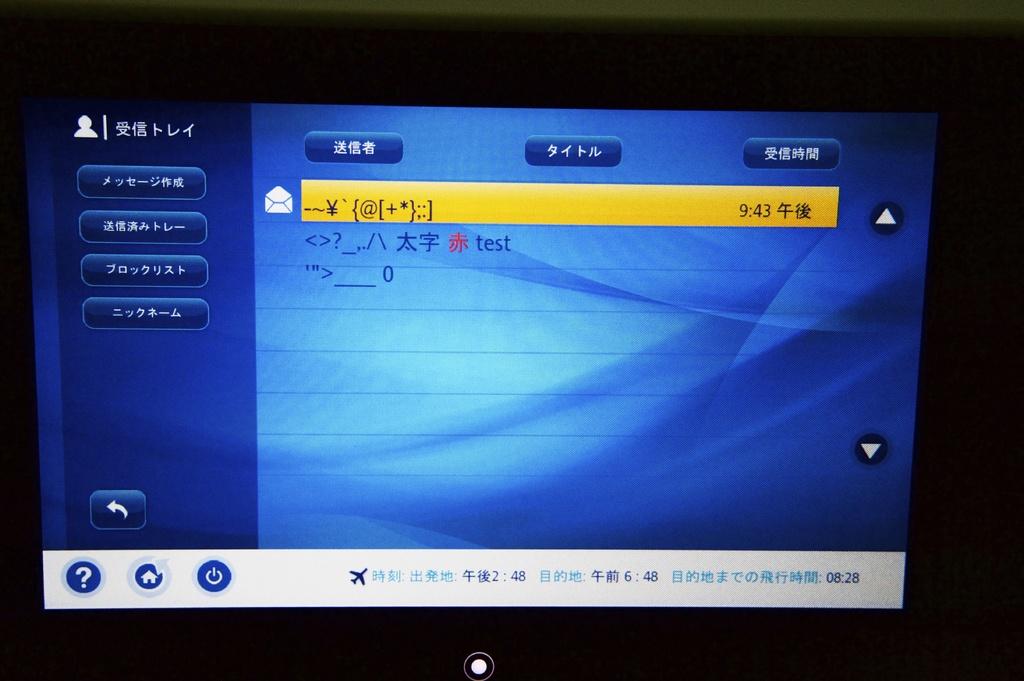What time s displayed in yellow?
Provide a succinct answer. 9:43. What is the time at the very bottom left of the monitor?
Offer a very short reply. 2:48. 